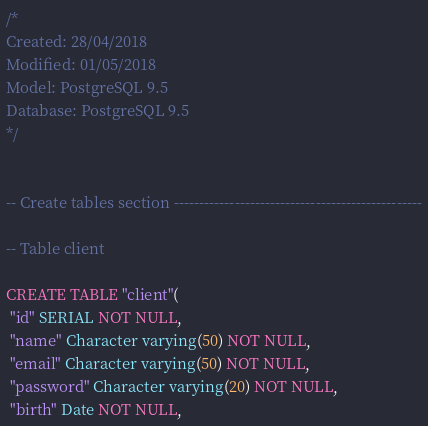Convert code to text. <code><loc_0><loc_0><loc_500><loc_500><_SQL_>/*
Created: 28/04/2018
Modified: 01/05/2018
Model: PostgreSQL 9.5
Database: PostgreSQL 9.5
*/


-- Create tables section -------------------------------------------------

-- Table client

CREATE TABLE "client"(
 "id" SERIAL NOT NULL,
 "name" Character varying(50) NOT NULL,
 "email" Character varying(50) NOT NULL,
 "password" Character varying(20) NOT NULL,
 "birth" Date NOT NULL,</code> 